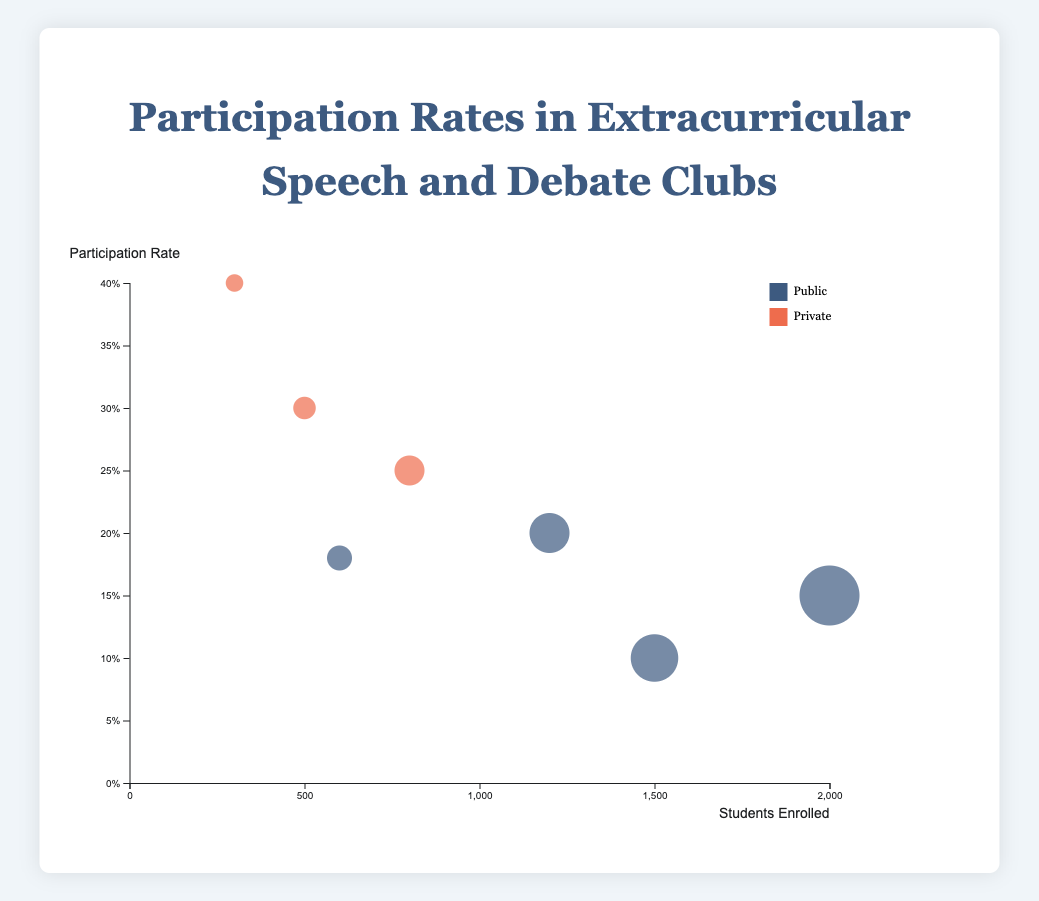What is the title of the figure? The title is typically located at the top of the chart and provides an overall description of what the chart is about.
Answer: Participation Rates in Extracurricular Speech and Debate Clubs How many schools are represented in the bubble chart? The number of bubbles in the chart corresponds to the number of schools represented.
Answer: 7 Which school has the highest participation rate? By comparing the positions of the bubbles on the y-axis, the school with the highest position indicates the highest participation rate.
Answer: Hillcrest Prep What is the enrollment size of Greenwood High School? Find the bubble representing Greenwood High School and check its corresponding x-axis value, which shows the student enrollment.
Answer: 2000 How does the participation rate of Hillcrest Prep compare to Silver Oak Academy? Compare the y-axis positions of the bubbles for Hillcrest Prep and Silver Oak Academy to determine which has a higher participation rate.
Answer: Hillcrest Prep has a higher participation rate Which type of school (Public or Private) generally has higher participation rates? Compare the overall positioning on the y-axis between the Public and Private school bubbles to see which type tends to be higher.
Answer: Private schools What is the average student enrollment for all schools? Add up the student enrollments of all schools and divide by the number of schools: (2000 + 500 + 1500 + 800 + 1200 + 600 + 300) / 7.
Answer: 986 Which school has the smallest bubble size, and what does this indicate? The smallest bubble represents the school with the lowest student enrollment.
Answer: Hillcrest Prep Compare the participation rate of Mountain Ridge Academy to the participation rate of Starlight Charter School. Examine the y-axis values corresponding to the bubbles for these two schools to compare their participation rates.
Answer: Mountain Ridge Academy has a higher participation rate Is there a visible trend between school size and participation rate? Analyze the scatter of bubbles across the x and y axes to determine if there's any correlation (e.g., larger schools tend to have lower/higher participation rates).
Answer: No clear trend visible 